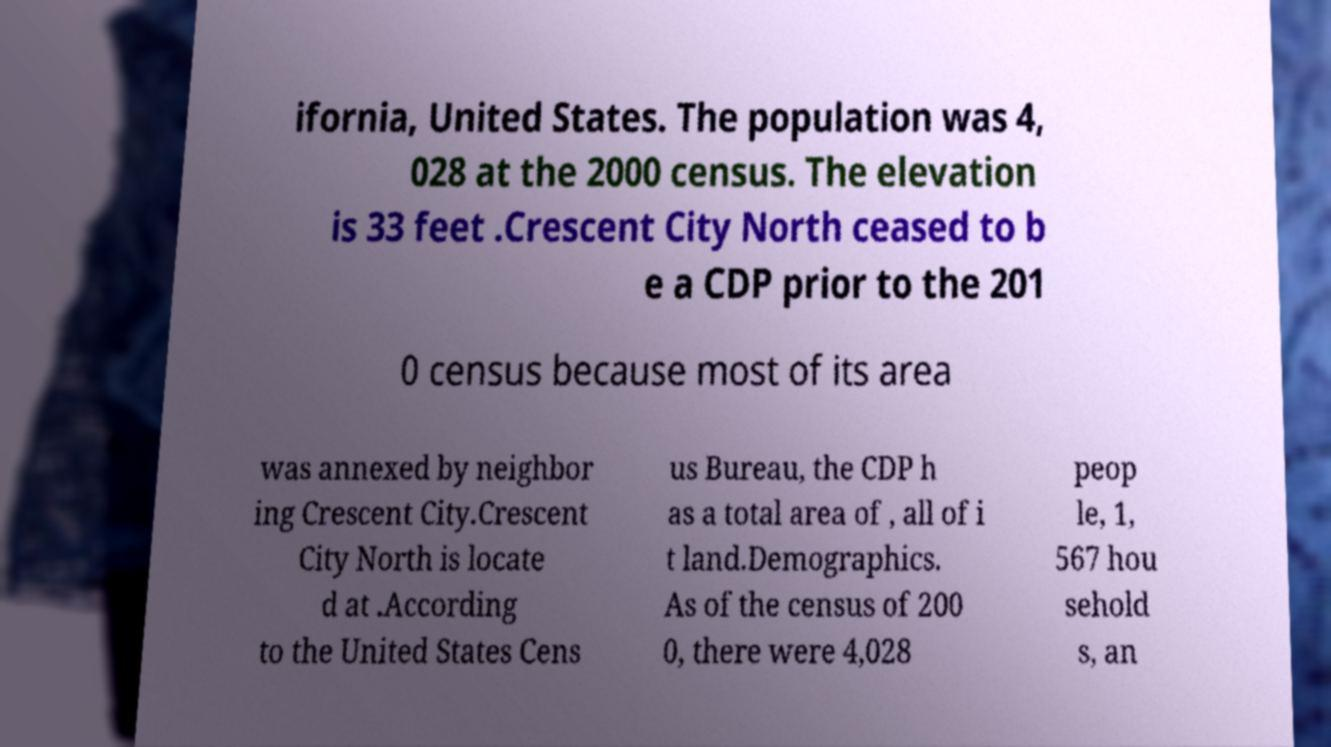For documentation purposes, I need the text within this image transcribed. Could you provide that? ifornia, United States. The population was 4, 028 at the 2000 census. The elevation is 33 feet .Crescent City North ceased to b e a CDP prior to the 201 0 census because most of its area was annexed by neighbor ing Crescent City.Crescent City North is locate d at .According to the United States Cens us Bureau, the CDP h as a total area of , all of i t land.Demographics. As of the census of 200 0, there were 4,028 peop le, 1, 567 hou sehold s, an 